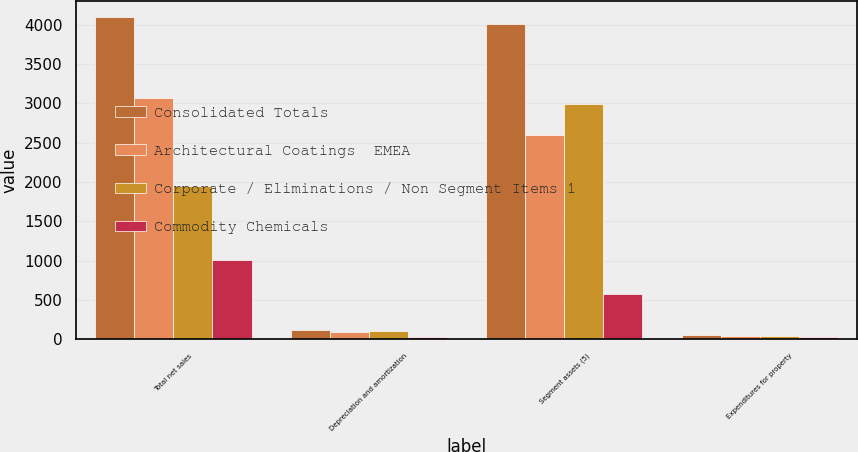<chart> <loc_0><loc_0><loc_500><loc_500><stacked_bar_chart><ecel><fcel>Total net sales<fcel>Depreciation and amortization<fcel>Segment assets (5)<fcel>Expenditures for property<nl><fcel>Consolidated Totals<fcel>4095<fcel>120<fcel>4003<fcel>51<nl><fcel>Architectural Coatings  EMEA<fcel>3068<fcel>98<fcel>2592<fcel>48<nl><fcel>Corporate / Eliminations / Non Segment Items 1<fcel>1952<fcel>109<fcel>2987<fcel>38<nl><fcel>Commodity Chemicals<fcel>1005<fcel>36<fcel>576<fcel>32<nl></chart> 